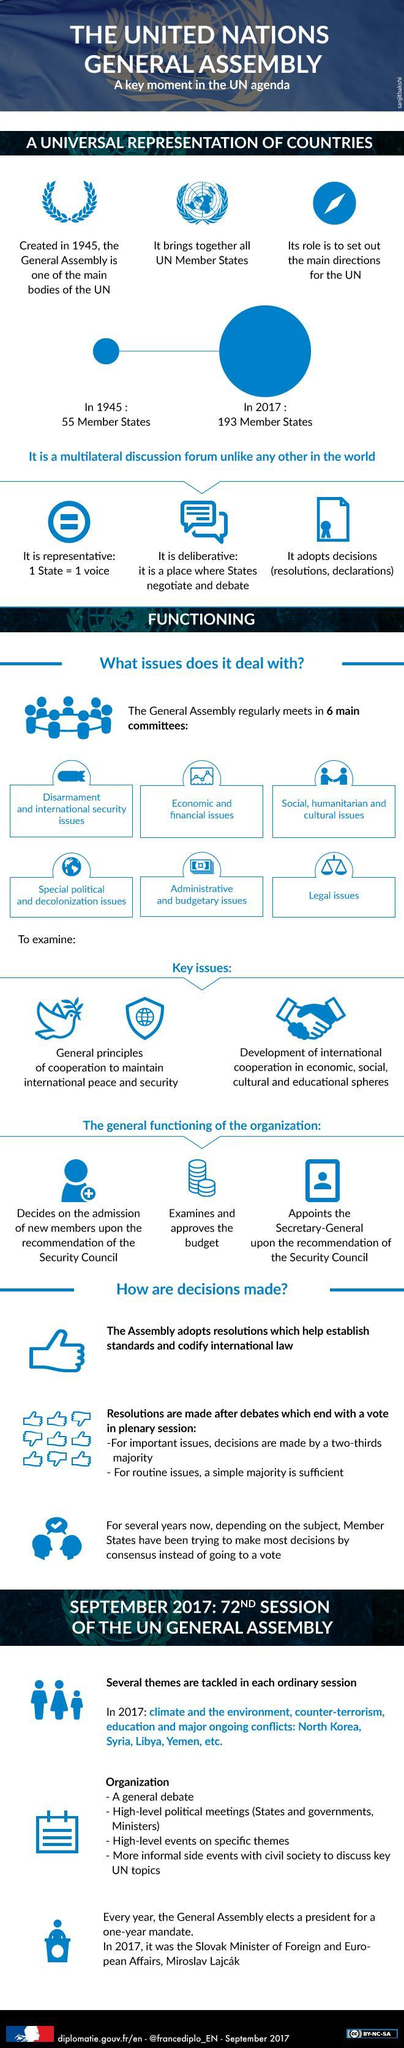How many key issues does the UN deal with ?
Answer the question with a short phrase. 2 How many member states have increased in the UN since 1945? 138 How many countries had major ongoing conflicts in 2017? 4 